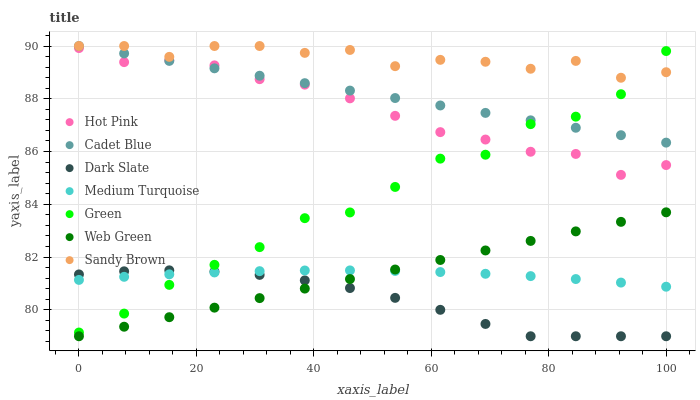Does Dark Slate have the minimum area under the curve?
Answer yes or no. Yes. Does Sandy Brown have the maximum area under the curve?
Answer yes or no. Yes. Does Hot Pink have the minimum area under the curve?
Answer yes or no. No. Does Hot Pink have the maximum area under the curve?
Answer yes or no. No. Is Cadet Blue the smoothest?
Answer yes or no. Yes. Is Green the roughest?
Answer yes or no. Yes. Is Hot Pink the smoothest?
Answer yes or no. No. Is Hot Pink the roughest?
Answer yes or no. No. Does Web Green have the lowest value?
Answer yes or no. Yes. Does Hot Pink have the lowest value?
Answer yes or no. No. Does Sandy Brown have the highest value?
Answer yes or no. Yes. Does Hot Pink have the highest value?
Answer yes or no. No. Is Web Green less than Sandy Brown?
Answer yes or no. Yes. Is Cadet Blue greater than Dark Slate?
Answer yes or no. Yes. Does Web Green intersect Medium Turquoise?
Answer yes or no. Yes. Is Web Green less than Medium Turquoise?
Answer yes or no. No. Is Web Green greater than Medium Turquoise?
Answer yes or no. No. Does Web Green intersect Sandy Brown?
Answer yes or no. No. 